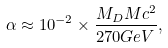Convert formula to latex. <formula><loc_0><loc_0><loc_500><loc_500>\alpha \approx 1 0 ^ { - 2 } \times \frac { M _ { D } M c ^ { 2 } } { 2 7 0 G e V } ,</formula> 